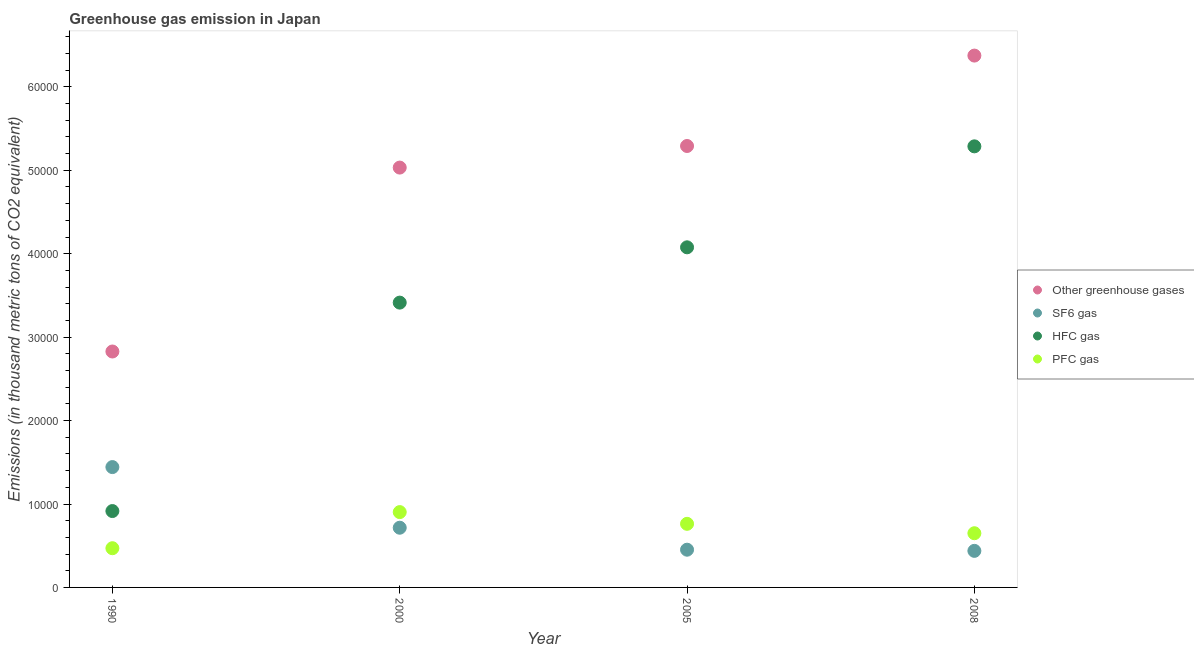What is the emission of sf6 gas in 2005?
Provide a succinct answer. 4522.3. Across all years, what is the maximum emission of hfc gas?
Make the answer very short. 5.29e+04. Across all years, what is the minimum emission of greenhouse gases?
Provide a succinct answer. 2.83e+04. In which year was the emission of greenhouse gases maximum?
Make the answer very short. 2008. What is the total emission of pfc gas in the graph?
Offer a very short reply. 2.78e+04. What is the difference between the emission of pfc gas in 2000 and that in 2008?
Keep it short and to the point. 2533.7. What is the difference between the emission of sf6 gas in 2000 and the emission of hfc gas in 2005?
Provide a short and direct response. -3.36e+04. What is the average emission of pfc gas per year?
Make the answer very short. 6962.38. In the year 1990, what is the difference between the emission of pfc gas and emission of greenhouse gases?
Keep it short and to the point. -2.36e+04. What is the ratio of the emission of greenhouse gases in 1990 to that in 2005?
Your answer should be compact. 0.53. Is the emission of hfc gas in 2000 less than that in 2005?
Offer a terse response. Yes. Is the difference between the emission of pfc gas in 2005 and 2008 greater than the difference between the emission of greenhouse gases in 2005 and 2008?
Offer a very short reply. Yes. What is the difference between the highest and the second highest emission of pfc gas?
Give a very brief answer. 1406.2. What is the difference between the highest and the lowest emission of pfc gas?
Provide a succinct answer. 4329.8. Is the sum of the emission of sf6 gas in 1990 and 2005 greater than the maximum emission of hfc gas across all years?
Your response must be concise. No. Is it the case that in every year, the sum of the emission of pfc gas and emission of hfc gas is greater than the sum of emission of sf6 gas and emission of greenhouse gases?
Your answer should be compact. No. Is it the case that in every year, the sum of the emission of greenhouse gases and emission of sf6 gas is greater than the emission of hfc gas?
Your answer should be compact. Yes. Is the emission of pfc gas strictly less than the emission of hfc gas over the years?
Make the answer very short. Yes. How many years are there in the graph?
Make the answer very short. 4. Does the graph contain any zero values?
Your answer should be very brief. No. Where does the legend appear in the graph?
Keep it short and to the point. Center right. What is the title of the graph?
Give a very brief answer. Greenhouse gas emission in Japan. What is the label or title of the Y-axis?
Your answer should be very brief. Emissions (in thousand metric tons of CO2 equivalent). What is the Emissions (in thousand metric tons of CO2 equivalent) in Other greenhouse gases in 1990?
Your answer should be compact. 2.83e+04. What is the Emissions (in thousand metric tons of CO2 equivalent) in SF6 gas in 1990?
Provide a short and direct response. 1.44e+04. What is the Emissions (in thousand metric tons of CO2 equivalent) in HFC gas in 1990?
Your answer should be very brief. 9154.3. What is the Emissions (in thousand metric tons of CO2 equivalent) in PFC gas in 1990?
Offer a very short reply. 4700. What is the Emissions (in thousand metric tons of CO2 equivalent) of Other greenhouse gases in 2000?
Make the answer very short. 5.03e+04. What is the Emissions (in thousand metric tons of CO2 equivalent) of SF6 gas in 2000?
Offer a very short reply. 7156.6. What is the Emissions (in thousand metric tons of CO2 equivalent) in HFC gas in 2000?
Provide a succinct answer. 3.41e+04. What is the Emissions (in thousand metric tons of CO2 equivalent) in PFC gas in 2000?
Ensure brevity in your answer.  9029.8. What is the Emissions (in thousand metric tons of CO2 equivalent) in Other greenhouse gases in 2005?
Your answer should be very brief. 5.29e+04. What is the Emissions (in thousand metric tons of CO2 equivalent) in SF6 gas in 2005?
Give a very brief answer. 4522.3. What is the Emissions (in thousand metric tons of CO2 equivalent) in HFC gas in 2005?
Ensure brevity in your answer.  4.08e+04. What is the Emissions (in thousand metric tons of CO2 equivalent) in PFC gas in 2005?
Give a very brief answer. 7623.6. What is the Emissions (in thousand metric tons of CO2 equivalent) in Other greenhouse gases in 2008?
Provide a short and direct response. 6.38e+04. What is the Emissions (in thousand metric tons of CO2 equivalent) of SF6 gas in 2008?
Your answer should be compact. 4382.7. What is the Emissions (in thousand metric tons of CO2 equivalent) in HFC gas in 2008?
Offer a very short reply. 5.29e+04. What is the Emissions (in thousand metric tons of CO2 equivalent) of PFC gas in 2008?
Offer a very short reply. 6496.1. Across all years, what is the maximum Emissions (in thousand metric tons of CO2 equivalent) of Other greenhouse gases?
Your answer should be very brief. 6.38e+04. Across all years, what is the maximum Emissions (in thousand metric tons of CO2 equivalent) in SF6 gas?
Your response must be concise. 1.44e+04. Across all years, what is the maximum Emissions (in thousand metric tons of CO2 equivalent) in HFC gas?
Provide a short and direct response. 5.29e+04. Across all years, what is the maximum Emissions (in thousand metric tons of CO2 equivalent) in PFC gas?
Offer a very short reply. 9029.8. Across all years, what is the minimum Emissions (in thousand metric tons of CO2 equivalent) in Other greenhouse gases?
Give a very brief answer. 2.83e+04. Across all years, what is the minimum Emissions (in thousand metric tons of CO2 equivalent) in SF6 gas?
Provide a succinct answer. 4382.7. Across all years, what is the minimum Emissions (in thousand metric tons of CO2 equivalent) in HFC gas?
Your answer should be very brief. 9154.3. Across all years, what is the minimum Emissions (in thousand metric tons of CO2 equivalent) in PFC gas?
Offer a terse response. 4700. What is the total Emissions (in thousand metric tons of CO2 equivalent) in Other greenhouse gases in the graph?
Your response must be concise. 1.95e+05. What is the total Emissions (in thousand metric tons of CO2 equivalent) in SF6 gas in the graph?
Provide a succinct answer. 3.05e+04. What is the total Emissions (in thousand metric tons of CO2 equivalent) in HFC gas in the graph?
Your answer should be very brief. 1.37e+05. What is the total Emissions (in thousand metric tons of CO2 equivalent) of PFC gas in the graph?
Offer a very short reply. 2.78e+04. What is the difference between the Emissions (in thousand metric tons of CO2 equivalent) of Other greenhouse gases in 1990 and that in 2000?
Provide a short and direct response. -2.20e+04. What is the difference between the Emissions (in thousand metric tons of CO2 equivalent) in SF6 gas in 1990 and that in 2000?
Offer a terse response. 7269.2. What is the difference between the Emissions (in thousand metric tons of CO2 equivalent) in HFC gas in 1990 and that in 2000?
Provide a short and direct response. -2.50e+04. What is the difference between the Emissions (in thousand metric tons of CO2 equivalent) in PFC gas in 1990 and that in 2000?
Provide a succinct answer. -4329.8. What is the difference between the Emissions (in thousand metric tons of CO2 equivalent) in Other greenhouse gases in 1990 and that in 2005?
Keep it short and to the point. -2.46e+04. What is the difference between the Emissions (in thousand metric tons of CO2 equivalent) in SF6 gas in 1990 and that in 2005?
Provide a short and direct response. 9903.5. What is the difference between the Emissions (in thousand metric tons of CO2 equivalent) of HFC gas in 1990 and that in 2005?
Ensure brevity in your answer.  -3.16e+04. What is the difference between the Emissions (in thousand metric tons of CO2 equivalent) of PFC gas in 1990 and that in 2005?
Your answer should be compact. -2923.6. What is the difference between the Emissions (in thousand metric tons of CO2 equivalent) of Other greenhouse gases in 1990 and that in 2008?
Ensure brevity in your answer.  -3.55e+04. What is the difference between the Emissions (in thousand metric tons of CO2 equivalent) in SF6 gas in 1990 and that in 2008?
Provide a short and direct response. 1.00e+04. What is the difference between the Emissions (in thousand metric tons of CO2 equivalent) of HFC gas in 1990 and that in 2008?
Provide a succinct answer. -4.37e+04. What is the difference between the Emissions (in thousand metric tons of CO2 equivalent) of PFC gas in 1990 and that in 2008?
Offer a terse response. -1796.1. What is the difference between the Emissions (in thousand metric tons of CO2 equivalent) in Other greenhouse gases in 2000 and that in 2005?
Your answer should be compact. -2588.2. What is the difference between the Emissions (in thousand metric tons of CO2 equivalent) in SF6 gas in 2000 and that in 2005?
Keep it short and to the point. 2634.3. What is the difference between the Emissions (in thousand metric tons of CO2 equivalent) of HFC gas in 2000 and that in 2005?
Your answer should be compact. -6628.7. What is the difference between the Emissions (in thousand metric tons of CO2 equivalent) in PFC gas in 2000 and that in 2005?
Make the answer very short. 1406.2. What is the difference between the Emissions (in thousand metric tons of CO2 equivalent) in Other greenhouse gases in 2000 and that in 2008?
Provide a succinct answer. -1.34e+04. What is the difference between the Emissions (in thousand metric tons of CO2 equivalent) in SF6 gas in 2000 and that in 2008?
Your answer should be very brief. 2773.9. What is the difference between the Emissions (in thousand metric tons of CO2 equivalent) of HFC gas in 2000 and that in 2008?
Offer a terse response. -1.87e+04. What is the difference between the Emissions (in thousand metric tons of CO2 equivalent) of PFC gas in 2000 and that in 2008?
Offer a very short reply. 2533.7. What is the difference between the Emissions (in thousand metric tons of CO2 equivalent) of Other greenhouse gases in 2005 and that in 2008?
Make the answer very short. -1.08e+04. What is the difference between the Emissions (in thousand metric tons of CO2 equivalent) of SF6 gas in 2005 and that in 2008?
Your answer should be compact. 139.6. What is the difference between the Emissions (in thousand metric tons of CO2 equivalent) of HFC gas in 2005 and that in 2008?
Offer a terse response. -1.21e+04. What is the difference between the Emissions (in thousand metric tons of CO2 equivalent) of PFC gas in 2005 and that in 2008?
Provide a short and direct response. 1127.5. What is the difference between the Emissions (in thousand metric tons of CO2 equivalent) of Other greenhouse gases in 1990 and the Emissions (in thousand metric tons of CO2 equivalent) of SF6 gas in 2000?
Make the answer very short. 2.11e+04. What is the difference between the Emissions (in thousand metric tons of CO2 equivalent) of Other greenhouse gases in 1990 and the Emissions (in thousand metric tons of CO2 equivalent) of HFC gas in 2000?
Ensure brevity in your answer.  -5859.7. What is the difference between the Emissions (in thousand metric tons of CO2 equivalent) of Other greenhouse gases in 1990 and the Emissions (in thousand metric tons of CO2 equivalent) of PFC gas in 2000?
Make the answer very short. 1.93e+04. What is the difference between the Emissions (in thousand metric tons of CO2 equivalent) of SF6 gas in 1990 and the Emissions (in thousand metric tons of CO2 equivalent) of HFC gas in 2000?
Offer a very short reply. -1.97e+04. What is the difference between the Emissions (in thousand metric tons of CO2 equivalent) in SF6 gas in 1990 and the Emissions (in thousand metric tons of CO2 equivalent) in PFC gas in 2000?
Ensure brevity in your answer.  5396. What is the difference between the Emissions (in thousand metric tons of CO2 equivalent) in HFC gas in 1990 and the Emissions (in thousand metric tons of CO2 equivalent) in PFC gas in 2000?
Offer a terse response. 124.5. What is the difference between the Emissions (in thousand metric tons of CO2 equivalent) of Other greenhouse gases in 1990 and the Emissions (in thousand metric tons of CO2 equivalent) of SF6 gas in 2005?
Provide a short and direct response. 2.38e+04. What is the difference between the Emissions (in thousand metric tons of CO2 equivalent) of Other greenhouse gases in 1990 and the Emissions (in thousand metric tons of CO2 equivalent) of HFC gas in 2005?
Your response must be concise. -1.25e+04. What is the difference between the Emissions (in thousand metric tons of CO2 equivalent) of Other greenhouse gases in 1990 and the Emissions (in thousand metric tons of CO2 equivalent) of PFC gas in 2005?
Your answer should be very brief. 2.07e+04. What is the difference between the Emissions (in thousand metric tons of CO2 equivalent) in SF6 gas in 1990 and the Emissions (in thousand metric tons of CO2 equivalent) in HFC gas in 2005?
Your answer should be compact. -2.63e+04. What is the difference between the Emissions (in thousand metric tons of CO2 equivalent) of SF6 gas in 1990 and the Emissions (in thousand metric tons of CO2 equivalent) of PFC gas in 2005?
Give a very brief answer. 6802.2. What is the difference between the Emissions (in thousand metric tons of CO2 equivalent) in HFC gas in 1990 and the Emissions (in thousand metric tons of CO2 equivalent) in PFC gas in 2005?
Ensure brevity in your answer.  1530.7. What is the difference between the Emissions (in thousand metric tons of CO2 equivalent) in Other greenhouse gases in 1990 and the Emissions (in thousand metric tons of CO2 equivalent) in SF6 gas in 2008?
Your answer should be very brief. 2.39e+04. What is the difference between the Emissions (in thousand metric tons of CO2 equivalent) in Other greenhouse gases in 1990 and the Emissions (in thousand metric tons of CO2 equivalent) in HFC gas in 2008?
Your answer should be very brief. -2.46e+04. What is the difference between the Emissions (in thousand metric tons of CO2 equivalent) in Other greenhouse gases in 1990 and the Emissions (in thousand metric tons of CO2 equivalent) in PFC gas in 2008?
Your response must be concise. 2.18e+04. What is the difference between the Emissions (in thousand metric tons of CO2 equivalent) of SF6 gas in 1990 and the Emissions (in thousand metric tons of CO2 equivalent) of HFC gas in 2008?
Provide a succinct answer. -3.84e+04. What is the difference between the Emissions (in thousand metric tons of CO2 equivalent) in SF6 gas in 1990 and the Emissions (in thousand metric tons of CO2 equivalent) in PFC gas in 2008?
Offer a very short reply. 7929.7. What is the difference between the Emissions (in thousand metric tons of CO2 equivalent) of HFC gas in 1990 and the Emissions (in thousand metric tons of CO2 equivalent) of PFC gas in 2008?
Provide a succinct answer. 2658.2. What is the difference between the Emissions (in thousand metric tons of CO2 equivalent) in Other greenhouse gases in 2000 and the Emissions (in thousand metric tons of CO2 equivalent) in SF6 gas in 2005?
Offer a very short reply. 4.58e+04. What is the difference between the Emissions (in thousand metric tons of CO2 equivalent) in Other greenhouse gases in 2000 and the Emissions (in thousand metric tons of CO2 equivalent) in HFC gas in 2005?
Provide a short and direct response. 9557.7. What is the difference between the Emissions (in thousand metric tons of CO2 equivalent) in Other greenhouse gases in 2000 and the Emissions (in thousand metric tons of CO2 equivalent) in PFC gas in 2005?
Keep it short and to the point. 4.27e+04. What is the difference between the Emissions (in thousand metric tons of CO2 equivalent) in SF6 gas in 2000 and the Emissions (in thousand metric tons of CO2 equivalent) in HFC gas in 2005?
Keep it short and to the point. -3.36e+04. What is the difference between the Emissions (in thousand metric tons of CO2 equivalent) of SF6 gas in 2000 and the Emissions (in thousand metric tons of CO2 equivalent) of PFC gas in 2005?
Give a very brief answer. -467. What is the difference between the Emissions (in thousand metric tons of CO2 equivalent) in HFC gas in 2000 and the Emissions (in thousand metric tons of CO2 equivalent) in PFC gas in 2005?
Your answer should be very brief. 2.65e+04. What is the difference between the Emissions (in thousand metric tons of CO2 equivalent) of Other greenhouse gases in 2000 and the Emissions (in thousand metric tons of CO2 equivalent) of SF6 gas in 2008?
Provide a short and direct response. 4.59e+04. What is the difference between the Emissions (in thousand metric tons of CO2 equivalent) in Other greenhouse gases in 2000 and the Emissions (in thousand metric tons of CO2 equivalent) in HFC gas in 2008?
Your response must be concise. -2545.7. What is the difference between the Emissions (in thousand metric tons of CO2 equivalent) in Other greenhouse gases in 2000 and the Emissions (in thousand metric tons of CO2 equivalent) in PFC gas in 2008?
Your response must be concise. 4.38e+04. What is the difference between the Emissions (in thousand metric tons of CO2 equivalent) in SF6 gas in 2000 and the Emissions (in thousand metric tons of CO2 equivalent) in HFC gas in 2008?
Provide a succinct answer. -4.57e+04. What is the difference between the Emissions (in thousand metric tons of CO2 equivalent) in SF6 gas in 2000 and the Emissions (in thousand metric tons of CO2 equivalent) in PFC gas in 2008?
Offer a terse response. 660.5. What is the difference between the Emissions (in thousand metric tons of CO2 equivalent) of HFC gas in 2000 and the Emissions (in thousand metric tons of CO2 equivalent) of PFC gas in 2008?
Offer a terse response. 2.76e+04. What is the difference between the Emissions (in thousand metric tons of CO2 equivalent) of Other greenhouse gases in 2005 and the Emissions (in thousand metric tons of CO2 equivalent) of SF6 gas in 2008?
Make the answer very short. 4.85e+04. What is the difference between the Emissions (in thousand metric tons of CO2 equivalent) in Other greenhouse gases in 2005 and the Emissions (in thousand metric tons of CO2 equivalent) in HFC gas in 2008?
Provide a short and direct response. 42.5. What is the difference between the Emissions (in thousand metric tons of CO2 equivalent) of Other greenhouse gases in 2005 and the Emissions (in thousand metric tons of CO2 equivalent) of PFC gas in 2008?
Offer a very short reply. 4.64e+04. What is the difference between the Emissions (in thousand metric tons of CO2 equivalent) in SF6 gas in 2005 and the Emissions (in thousand metric tons of CO2 equivalent) in HFC gas in 2008?
Make the answer very short. -4.83e+04. What is the difference between the Emissions (in thousand metric tons of CO2 equivalent) in SF6 gas in 2005 and the Emissions (in thousand metric tons of CO2 equivalent) in PFC gas in 2008?
Ensure brevity in your answer.  -1973.8. What is the difference between the Emissions (in thousand metric tons of CO2 equivalent) in HFC gas in 2005 and the Emissions (in thousand metric tons of CO2 equivalent) in PFC gas in 2008?
Your answer should be very brief. 3.43e+04. What is the average Emissions (in thousand metric tons of CO2 equivalent) of Other greenhouse gases per year?
Give a very brief answer. 4.88e+04. What is the average Emissions (in thousand metric tons of CO2 equivalent) of SF6 gas per year?
Provide a succinct answer. 7621.85. What is the average Emissions (in thousand metric tons of CO2 equivalent) in HFC gas per year?
Provide a succinct answer. 3.42e+04. What is the average Emissions (in thousand metric tons of CO2 equivalent) of PFC gas per year?
Offer a terse response. 6962.38. In the year 1990, what is the difference between the Emissions (in thousand metric tons of CO2 equivalent) in Other greenhouse gases and Emissions (in thousand metric tons of CO2 equivalent) in SF6 gas?
Provide a short and direct response. 1.39e+04. In the year 1990, what is the difference between the Emissions (in thousand metric tons of CO2 equivalent) of Other greenhouse gases and Emissions (in thousand metric tons of CO2 equivalent) of HFC gas?
Provide a short and direct response. 1.91e+04. In the year 1990, what is the difference between the Emissions (in thousand metric tons of CO2 equivalent) of Other greenhouse gases and Emissions (in thousand metric tons of CO2 equivalent) of PFC gas?
Your answer should be compact. 2.36e+04. In the year 1990, what is the difference between the Emissions (in thousand metric tons of CO2 equivalent) of SF6 gas and Emissions (in thousand metric tons of CO2 equivalent) of HFC gas?
Your answer should be very brief. 5271.5. In the year 1990, what is the difference between the Emissions (in thousand metric tons of CO2 equivalent) in SF6 gas and Emissions (in thousand metric tons of CO2 equivalent) in PFC gas?
Offer a very short reply. 9725.8. In the year 1990, what is the difference between the Emissions (in thousand metric tons of CO2 equivalent) of HFC gas and Emissions (in thousand metric tons of CO2 equivalent) of PFC gas?
Keep it short and to the point. 4454.3. In the year 2000, what is the difference between the Emissions (in thousand metric tons of CO2 equivalent) in Other greenhouse gases and Emissions (in thousand metric tons of CO2 equivalent) in SF6 gas?
Your answer should be compact. 4.32e+04. In the year 2000, what is the difference between the Emissions (in thousand metric tons of CO2 equivalent) of Other greenhouse gases and Emissions (in thousand metric tons of CO2 equivalent) of HFC gas?
Provide a succinct answer. 1.62e+04. In the year 2000, what is the difference between the Emissions (in thousand metric tons of CO2 equivalent) of Other greenhouse gases and Emissions (in thousand metric tons of CO2 equivalent) of PFC gas?
Make the answer very short. 4.13e+04. In the year 2000, what is the difference between the Emissions (in thousand metric tons of CO2 equivalent) of SF6 gas and Emissions (in thousand metric tons of CO2 equivalent) of HFC gas?
Offer a very short reply. -2.70e+04. In the year 2000, what is the difference between the Emissions (in thousand metric tons of CO2 equivalent) in SF6 gas and Emissions (in thousand metric tons of CO2 equivalent) in PFC gas?
Provide a short and direct response. -1873.2. In the year 2000, what is the difference between the Emissions (in thousand metric tons of CO2 equivalent) of HFC gas and Emissions (in thousand metric tons of CO2 equivalent) of PFC gas?
Ensure brevity in your answer.  2.51e+04. In the year 2005, what is the difference between the Emissions (in thousand metric tons of CO2 equivalent) in Other greenhouse gases and Emissions (in thousand metric tons of CO2 equivalent) in SF6 gas?
Provide a short and direct response. 4.84e+04. In the year 2005, what is the difference between the Emissions (in thousand metric tons of CO2 equivalent) of Other greenhouse gases and Emissions (in thousand metric tons of CO2 equivalent) of HFC gas?
Your answer should be very brief. 1.21e+04. In the year 2005, what is the difference between the Emissions (in thousand metric tons of CO2 equivalent) of Other greenhouse gases and Emissions (in thousand metric tons of CO2 equivalent) of PFC gas?
Provide a short and direct response. 4.53e+04. In the year 2005, what is the difference between the Emissions (in thousand metric tons of CO2 equivalent) in SF6 gas and Emissions (in thousand metric tons of CO2 equivalent) in HFC gas?
Ensure brevity in your answer.  -3.62e+04. In the year 2005, what is the difference between the Emissions (in thousand metric tons of CO2 equivalent) in SF6 gas and Emissions (in thousand metric tons of CO2 equivalent) in PFC gas?
Provide a succinct answer. -3101.3. In the year 2005, what is the difference between the Emissions (in thousand metric tons of CO2 equivalent) of HFC gas and Emissions (in thousand metric tons of CO2 equivalent) of PFC gas?
Offer a very short reply. 3.31e+04. In the year 2008, what is the difference between the Emissions (in thousand metric tons of CO2 equivalent) in Other greenhouse gases and Emissions (in thousand metric tons of CO2 equivalent) in SF6 gas?
Provide a short and direct response. 5.94e+04. In the year 2008, what is the difference between the Emissions (in thousand metric tons of CO2 equivalent) in Other greenhouse gases and Emissions (in thousand metric tons of CO2 equivalent) in HFC gas?
Make the answer very short. 1.09e+04. In the year 2008, what is the difference between the Emissions (in thousand metric tons of CO2 equivalent) in Other greenhouse gases and Emissions (in thousand metric tons of CO2 equivalent) in PFC gas?
Your answer should be very brief. 5.73e+04. In the year 2008, what is the difference between the Emissions (in thousand metric tons of CO2 equivalent) of SF6 gas and Emissions (in thousand metric tons of CO2 equivalent) of HFC gas?
Make the answer very short. -4.85e+04. In the year 2008, what is the difference between the Emissions (in thousand metric tons of CO2 equivalent) of SF6 gas and Emissions (in thousand metric tons of CO2 equivalent) of PFC gas?
Your answer should be very brief. -2113.4. In the year 2008, what is the difference between the Emissions (in thousand metric tons of CO2 equivalent) in HFC gas and Emissions (in thousand metric tons of CO2 equivalent) in PFC gas?
Give a very brief answer. 4.64e+04. What is the ratio of the Emissions (in thousand metric tons of CO2 equivalent) of Other greenhouse gases in 1990 to that in 2000?
Your response must be concise. 0.56. What is the ratio of the Emissions (in thousand metric tons of CO2 equivalent) of SF6 gas in 1990 to that in 2000?
Ensure brevity in your answer.  2.02. What is the ratio of the Emissions (in thousand metric tons of CO2 equivalent) of HFC gas in 1990 to that in 2000?
Offer a terse response. 0.27. What is the ratio of the Emissions (in thousand metric tons of CO2 equivalent) in PFC gas in 1990 to that in 2000?
Ensure brevity in your answer.  0.52. What is the ratio of the Emissions (in thousand metric tons of CO2 equivalent) of Other greenhouse gases in 1990 to that in 2005?
Offer a very short reply. 0.53. What is the ratio of the Emissions (in thousand metric tons of CO2 equivalent) in SF6 gas in 1990 to that in 2005?
Your answer should be compact. 3.19. What is the ratio of the Emissions (in thousand metric tons of CO2 equivalent) in HFC gas in 1990 to that in 2005?
Provide a succinct answer. 0.22. What is the ratio of the Emissions (in thousand metric tons of CO2 equivalent) of PFC gas in 1990 to that in 2005?
Give a very brief answer. 0.62. What is the ratio of the Emissions (in thousand metric tons of CO2 equivalent) in Other greenhouse gases in 1990 to that in 2008?
Keep it short and to the point. 0.44. What is the ratio of the Emissions (in thousand metric tons of CO2 equivalent) of SF6 gas in 1990 to that in 2008?
Your answer should be compact. 3.29. What is the ratio of the Emissions (in thousand metric tons of CO2 equivalent) in HFC gas in 1990 to that in 2008?
Provide a succinct answer. 0.17. What is the ratio of the Emissions (in thousand metric tons of CO2 equivalent) of PFC gas in 1990 to that in 2008?
Offer a terse response. 0.72. What is the ratio of the Emissions (in thousand metric tons of CO2 equivalent) in Other greenhouse gases in 2000 to that in 2005?
Offer a very short reply. 0.95. What is the ratio of the Emissions (in thousand metric tons of CO2 equivalent) in SF6 gas in 2000 to that in 2005?
Your answer should be compact. 1.58. What is the ratio of the Emissions (in thousand metric tons of CO2 equivalent) in HFC gas in 2000 to that in 2005?
Ensure brevity in your answer.  0.84. What is the ratio of the Emissions (in thousand metric tons of CO2 equivalent) in PFC gas in 2000 to that in 2005?
Your answer should be very brief. 1.18. What is the ratio of the Emissions (in thousand metric tons of CO2 equivalent) in Other greenhouse gases in 2000 to that in 2008?
Provide a short and direct response. 0.79. What is the ratio of the Emissions (in thousand metric tons of CO2 equivalent) in SF6 gas in 2000 to that in 2008?
Provide a short and direct response. 1.63. What is the ratio of the Emissions (in thousand metric tons of CO2 equivalent) of HFC gas in 2000 to that in 2008?
Your answer should be compact. 0.65. What is the ratio of the Emissions (in thousand metric tons of CO2 equivalent) in PFC gas in 2000 to that in 2008?
Offer a very short reply. 1.39. What is the ratio of the Emissions (in thousand metric tons of CO2 equivalent) in Other greenhouse gases in 2005 to that in 2008?
Your answer should be very brief. 0.83. What is the ratio of the Emissions (in thousand metric tons of CO2 equivalent) in SF6 gas in 2005 to that in 2008?
Your answer should be compact. 1.03. What is the ratio of the Emissions (in thousand metric tons of CO2 equivalent) in HFC gas in 2005 to that in 2008?
Your answer should be very brief. 0.77. What is the ratio of the Emissions (in thousand metric tons of CO2 equivalent) of PFC gas in 2005 to that in 2008?
Ensure brevity in your answer.  1.17. What is the difference between the highest and the second highest Emissions (in thousand metric tons of CO2 equivalent) in Other greenhouse gases?
Ensure brevity in your answer.  1.08e+04. What is the difference between the highest and the second highest Emissions (in thousand metric tons of CO2 equivalent) in SF6 gas?
Give a very brief answer. 7269.2. What is the difference between the highest and the second highest Emissions (in thousand metric tons of CO2 equivalent) of HFC gas?
Offer a terse response. 1.21e+04. What is the difference between the highest and the second highest Emissions (in thousand metric tons of CO2 equivalent) of PFC gas?
Provide a succinct answer. 1406.2. What is the difference between the highest and the lowest Emissions (in thousand metric tons of CO2 equivalent) in Other greenhouse gases?
Offer a terse response. 3.55e+04. What is the difference between the highest and the lowest Emissions (in thousand metric tons of CO2 equivalent) of SF6 gas?
Offer a terse response. 1.00e+04. What is the difference between the highest and the lowest Emissions (in thousand metric tons of CO2 equivalent) in HFC gas?
Make the answer very short. 4.37e+04. What is the difference between the highest and the lowest Emissions (in thousand metric tons of CO2 equivalent) of PFC gas?
Provide a short and direct response. 4329.8. 